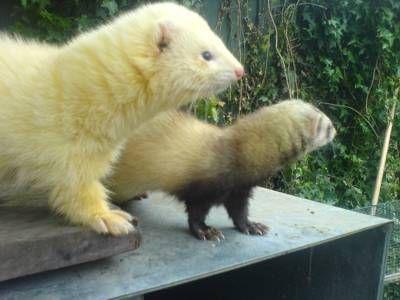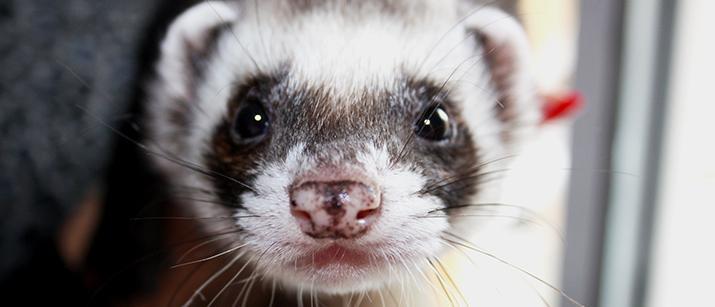The first image is the image on the left, the second image is the image on the right. Evaluate the accuracy of this statement regarding the images: "The left image shows side-by-side ferrets standing on their own feet, and the right image shows a single forward-facing ferret.". Is it true? Answer yes or no. Yes. The first image is the image on the left, the second image is the image on the right. For the images shown, is this caption "Two ferrets are standing." true? Answer yes or no. Yes. 